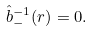<formula> <loc_0><loc_0><loc_500><loc_500>\hat { b } _ { - } ^ { - 1 } ( r ) = 0 .</formula> 